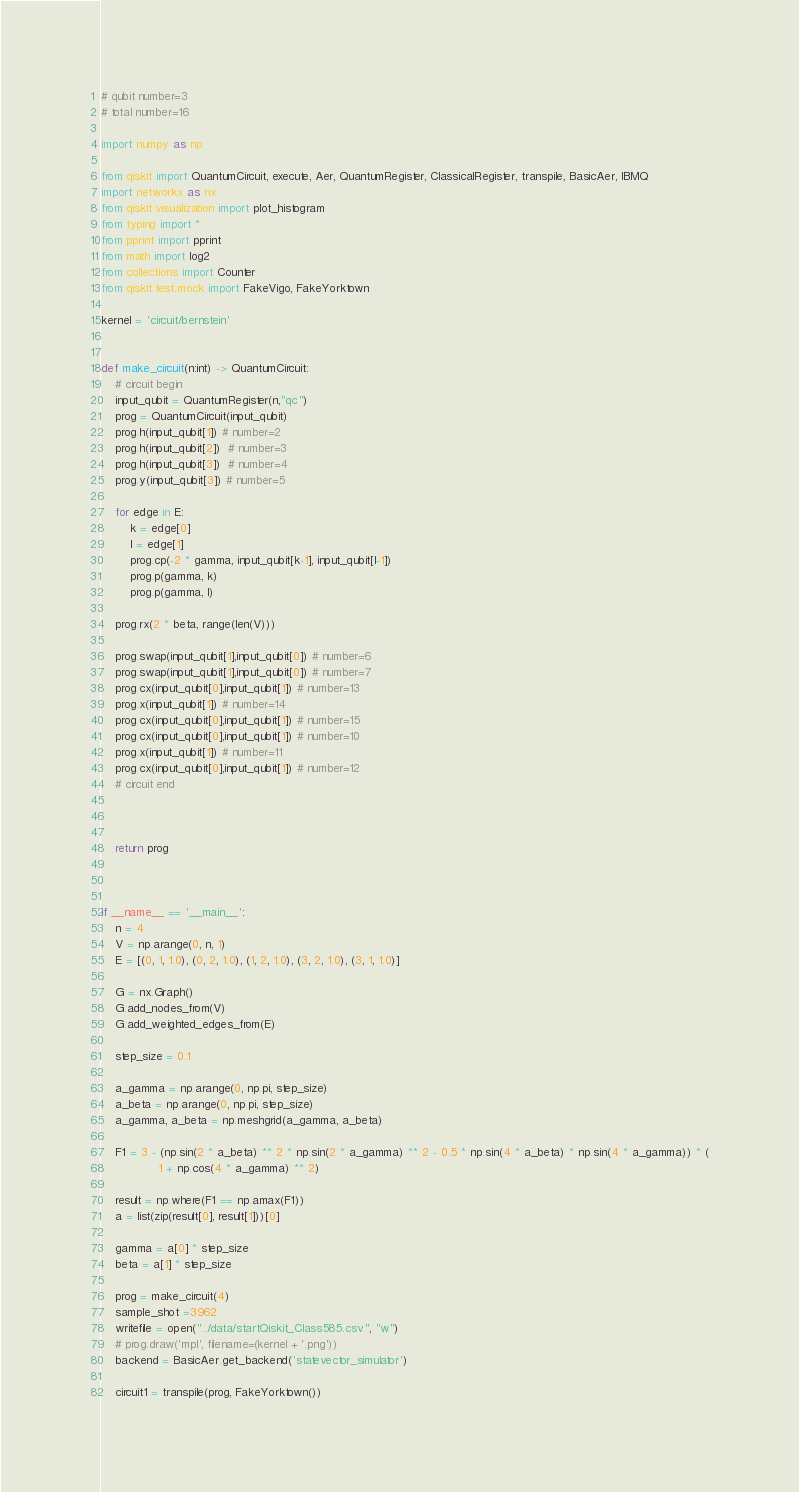Convert code to text. <code><loc_0><loc_0><loc_500><loc_500><_Python_># qubit number=3
# total number=16

import numpy as np

from qiskit import QuantumCircuit, execute, Aer, QuantumRegister, ClassicalRegister, transpile, BasicAer, IBMQ
import networkx as nx
from qiskit.visualization import plot_histogram
from typing import *
from pprint import pprint
from math import log2
from collections import Counter
from qiskit.test.mock import FakeVigo, FakeYorktown

kernel = 'circuit/bernstein'


def make_circuit(n:int) -> QuantumCircuit:
    # circuit begin
    input_qubit = QuantumRegister(n,"qc")
    prog = QuantumCircuit(input_qubit)
    prog.h(input_qubit[1]) # number=2
    prog.h(input_qubit[2])  # number=3
    prog.h(input_qubit[3])  # number=4
    prog.y(input_qubit[3]) # number=5

    for edge in E:
        k = edge[0]
        l = edge[1]
        prog.cp(-2 * gamma, input_qubit[k-1], input_qubit[l-1])
        prog.p(gamma, k)
        prog.p(gamma, l)

    prog.rx(2 * beta, range(len(V)))

    prog.swap(input_qubit[1],input_qubit[0]) # number=6
    prog.swap(input_qubit[1],input_qubit[0]) # number=7
    prog.cx(input_qubit[0],input_qubit[1]) # number=13
    prog.x(input_qubit[1]) # number=14
    prog.cx(input_qubit[0],input_qubit[1]) # number=15
    prog.cx(input_qubit[0],input_qubit[1]) # number=10
    prog.x(input_qubit[1]) # number=11
    prog.cx(input_qubit[0],input_qubit[1]) # number=12
    # circuit end



    return prog



if __name__ == '__main__':
    n = 4
    V = np.arange(0, n, 1)
    E = [(0, 1, 1.0), (0, 2, 1.0), (1, 2, 1.0), (3, 2, 1.0), (3, 1, 1.0)]

    G = nx.Graph()
    G.add_nodes_from(V)
    G.add_weighted_edges_from(E)

    step_size = 0.1

    a_gamma = np.arange(0, np.pi, step_size)
    a_beta = np.arange(0, np.pi, step_size)
    a_gamma, a_beta = np.meshgrid(a_gamma, a_beta)

    F1 = 3 - (np.sin(2 * a_beta) ** 2 * np.sin(2 * a_gamma) ** 2 - 0.5 * np.sin(4 * a_beta) * np.sin(4 * a_gamma)) * (
                1 + np.cos(4 * a_gamma) ** 2)

    result = np.where(F1 == np.amax(F1))
    a = list(zip(result[0], result[1]))[0]

    gamma = a[0] * step_size
    beta = a[1] * step_size

    prog = make_circuit(4)
    sample_shot =3962
    writefile = open("../data/startQiskit_Class585.csv", "w")
    # prog.draw('mpl', filename=(kernel + '.png'))
    backend = BasicAer.get_backend('statevector_simulator')

    circuit1 = transpile(prog, FakeYorktown())</code> 